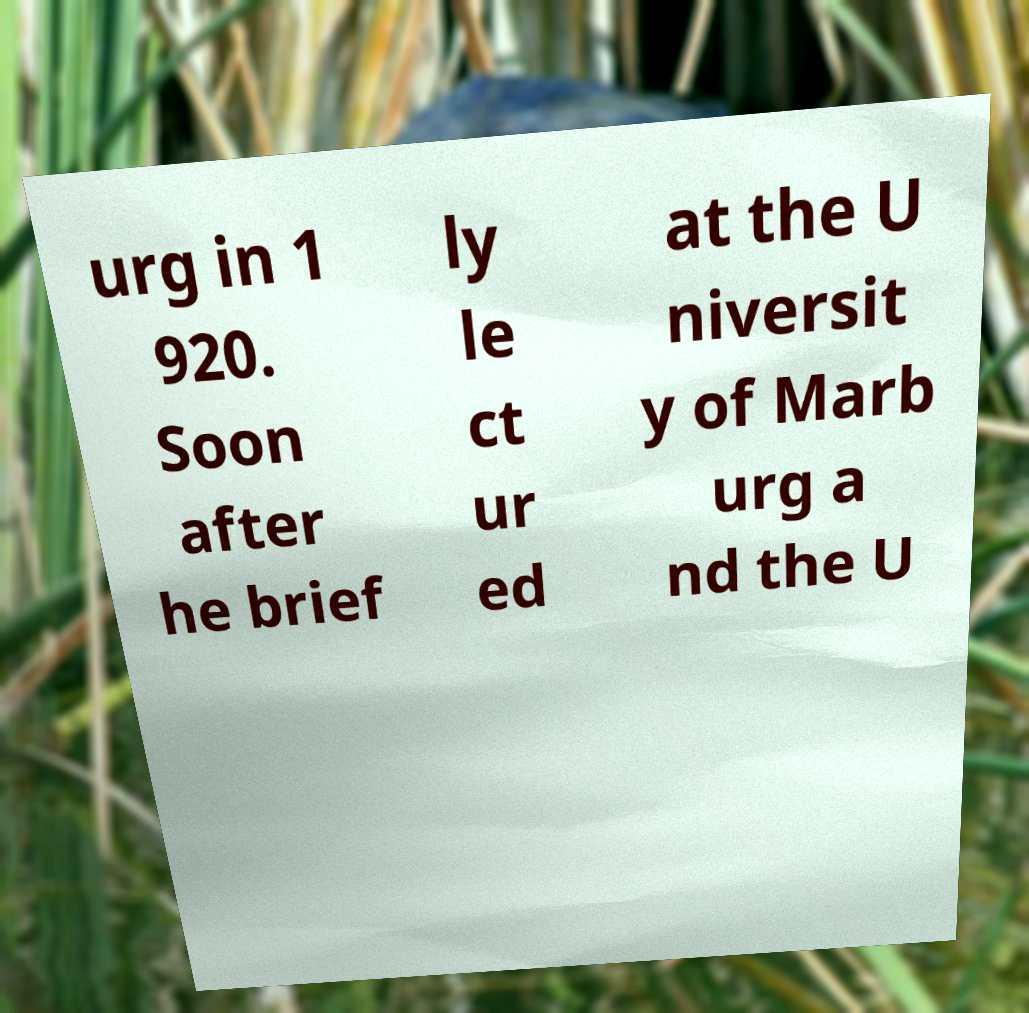Please identify and transcribe the text found in this image. urg in 1 920. Soon after he brief ly le ct ur ed at the U niversit y of Marb urg a nd the U 